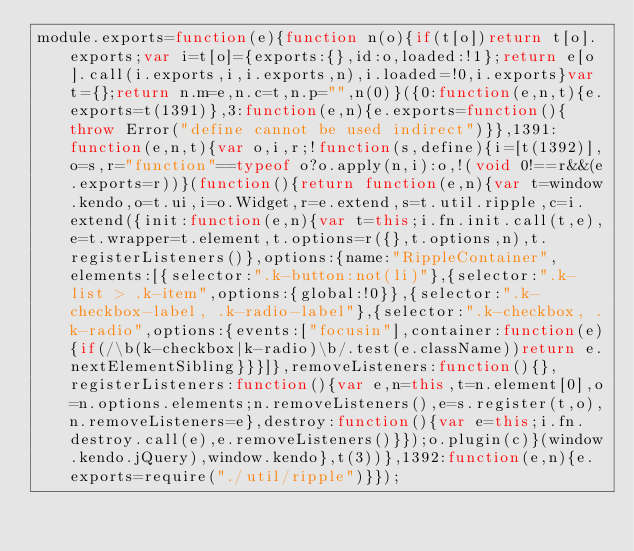<code> <loc_0><loc_0><loc_500><loc_500><_JavaScript_>module.exports=function(e){function n(o){if(t[o])return t[o].exports;var i=t[o]={exports:{},id:o,loaded:!1};return e[o].call(i.exports,i,i.exports,n),i.loaded=!0,i.exports}var t={};return n.m=e,n.c=t,n.p="",n(0)}({0:function(e,n,t){e.exports=t(1391)},3:function(e,n){e.exports=function(){throw Error("define cannot be used indirect")}},1391:function(e,n,t){var o,i,r;!function(s,define){i=[t(1392)],o=s,r="function"==typeof o?o.apply(n,i):o,!(void 0!==r&&(e.exports=r))}(function(){return function(e,n){var t=window.kendo,o=t.ui,i=o.Widget,r=e.extend,s=t.util.ripple,c=i.extend({init:function(e,n){var t=this;i.fn.init.call(t,e),e=t.wrapper=t.element,t.options=r({},t.options,n),t.registerListeners()},options:{name:"RippleContainer",elements:[{selector:".k-button:not(li)"},{selector:".k-list > .k-item",options:{global:!0}},{selector:".k-checkbox-label, .k-radio-label"},{selector:".k-checkbox, .k-radio",options:{events:["focusin"],container:function(e){if(/\b(k-checkbox|k-radio)\b/.test(e.className))return e.nextElementSibling}}}]},removeListeners:function(){},registerListeners:function(){var e,n=this,t=n.element[0],o=n.options.elements;n.removeListeners(),e=s.register(t,o),n.removeListeners=e},destroy:function(){var e=this;i.fn.destroy.call(e),e.removeListeners()}});o.plugin(c)}(window.kendo.jQuery),window.kendo},t(3))},1392:function(e,n){e.exports=require("./util/ripple")}});</code> 